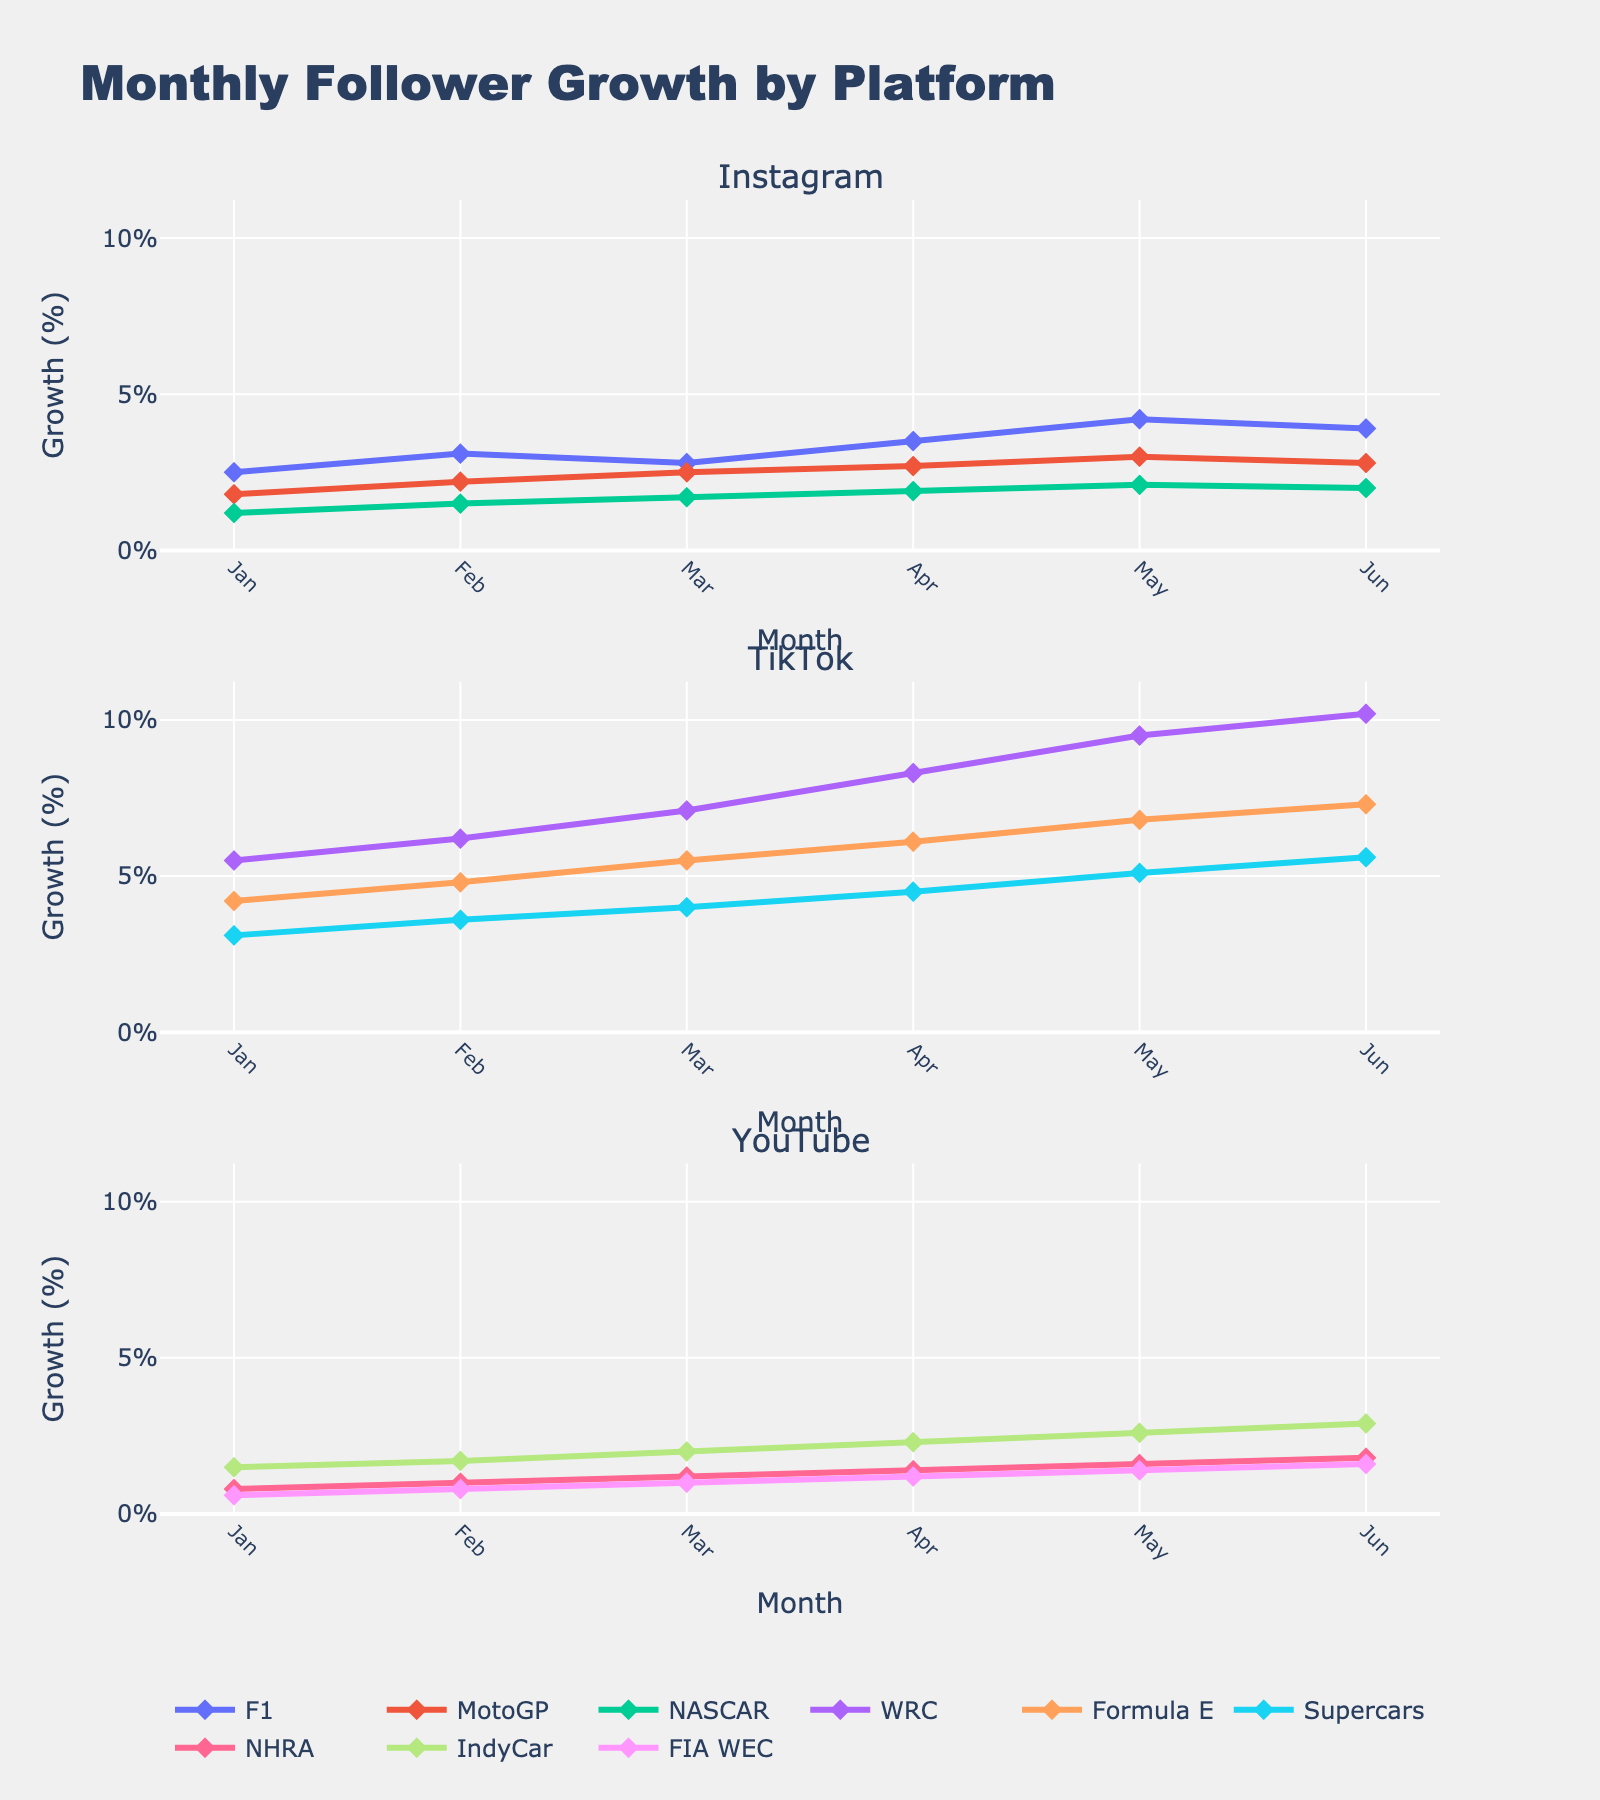Which show has the highest viewership rating in 2023? Look at the subplot for each show and check the viewership ratings for 2023. The Voice Kids Portugal has the highest rating of 26.3.
Answer: The Voice Kids Portugal What is the title of the figure? The title is placed at the top of the figure, summarizing the content of the subplots. It reads, "Viewership Ratings for Portuguese TV Shows (2020-2023)".
Answer: Viewership Ratings for Portuguese TV Shows (2020-2023) Which show had the greatest increase in viewership rating from 2020 to 2023? Calculate the difference in viewership ratings between 2020 and 2023 for each show. The Voice Kids Portugal increased from 22.5 to 26.3, a rise of 3.8, which is the largest increase.
Answer: The Voice Kids Portugal What is the viewership rating of Jornal da Noite in 2021? Locate the subplot for Jornal da Noite and identify the data point for 2021, which is 16.1 according to the figure.
Answer: 16.1 Which show exhibits a consistent increasing trend in viewership ratings from 2020 to 2023? Review the subplots and look for a show where the ratings continuously increase each year. Isto é Gozar Com Quem Trabalha increases from 17.9 (2020) to 18.5 (2021), 19.2 (2022), and then to 20.1 (2023).
Answer: Isto é Gozar Com Quem Trabalha What are the viewership ratings for Got Talent Portugal in 2020 and 2023? In the subplot for Got Talent Portugal, identify the data points corresponding to the years 2020 and 2023. The ratings are 14.8 and 15.9, respectively.
Answer: 14.8 and 15.9 Which show has the lowest viewership rating in 2022? Compare the 2022 data points across all subplots. Hell's Kitchen Portugal has the lowest rating with 15.1.
Answer: Hell's Kitchen Portugal How many shows have a 2023 viewership rating higher than 20? Check the ratings for 2023 across all subplots. Three shows have ratings higher than 20: The Voice Kids Portugal (26.3), Amor Amor (18.9), and Isto é Gozar Com Quem Trabalha (20.1).
Answer: 3 